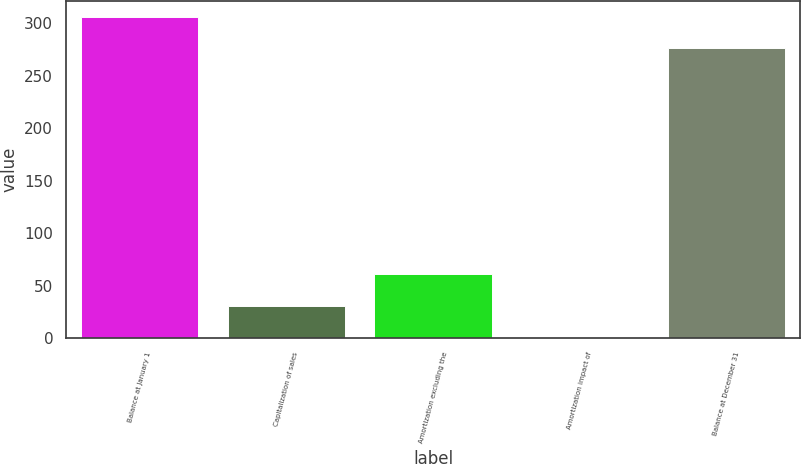Convert chart. <chart><loc_0><loc_0><loc_500><loc_500><bar_chart><fcel>Balance at January 1<fcel>Capitalization of sales<fcel>Amortization excluding the<fcel>Amortization impact of<fcel>Balance at December 31<nl><fcel>306.1<fcel>31.1<fcel>61.2<fcel>1<fcel>276<nl></chart> 